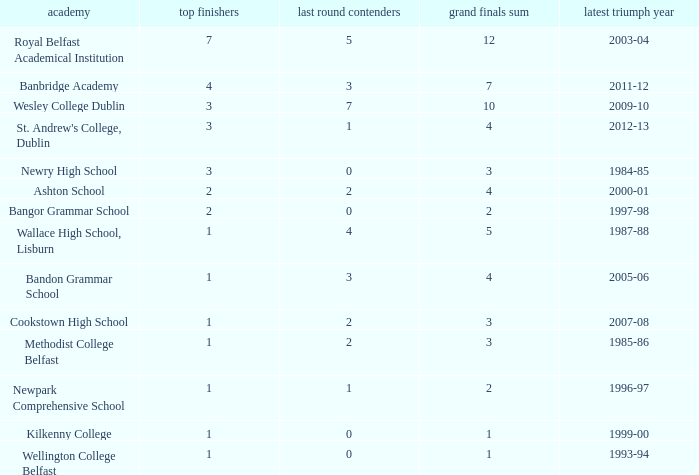In what year was the total finals at 10? 2009-10. 